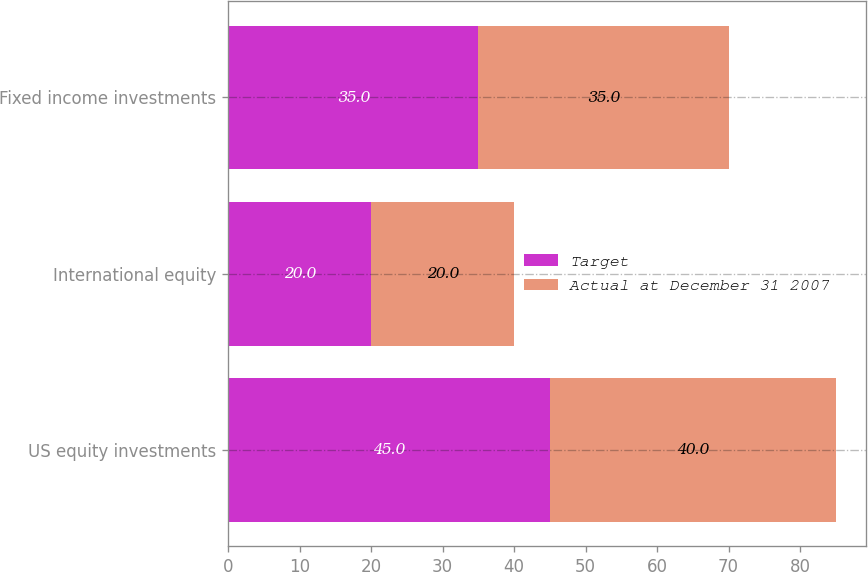Convert chart. <chart><loc_0><loc_0><loc_500><loc_500><stacked_bar_chart><ecel><fcel>US equity investments<fcel>International equity<fcel>Fixed income investments<nl><fcel>Target<fcel>45<fcel>20<fcel>35<nl><fcel>Actual at December 31 2007<fcel>40<fcel>20<fcel>35<nl></chart> 